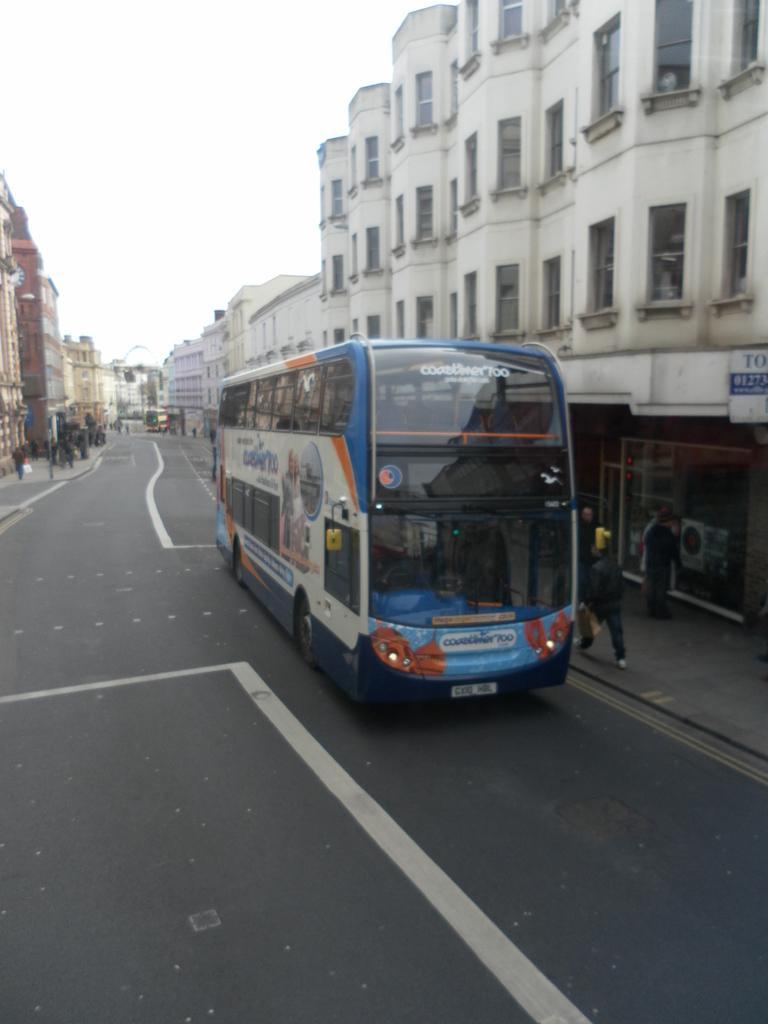How would you summarize this image in a sentence or two? In this image I can see a bus on the road. In the background I can see people, buildings and the sky. 